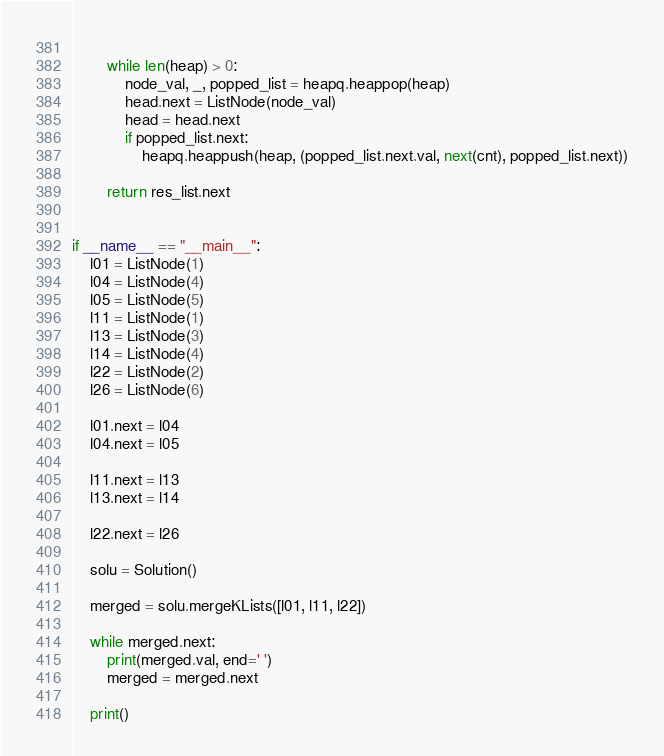<code> <loc_0><loc_0><loc_500><loc_500><_Python_>        
        while len(heap) > 0:
            node_val, _, popped_list = heapq.heappop(heap)
            head.next = ListNode(node_val)
            head = head.next
            if popped_list.next:
                heapq.heappush(heap, (popped_list.next.val, next(cnt), popped_list.next))
                
        return res_list.next
                

if __name__ == "__main__":
    l01 = ListNode(1)
    l04 = ListNode(4)
    l05 = ListNode(5)
    l11 = ListNode(1)
    l13 = ListNode(3)
    l14 = ListNode(4)
    l22 = ListNode(2)
    l26 = ListNode(6)

    l01.next = l04
    l04.next = l05

    l11.next = l13
    l13.next = l14

    l22.next = l26

    solu = Solution()
    
    merged = solu.mergeKLists([l01, l11, l22])
    
    while merged.next:
        print(merged.val, end=' ')
        merged = merged.next

    print()


</code> 